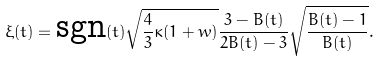Convert formula to latex. <formula><loc_0><loc_0><loc_500><loc_500>\xi ( t ) = \text {sgn} ( t ) \sqrt { \frac { 4 } { 3 } \kappa ( 1 + w ) } \frac { 3 - B ( t ) } { 2 B ( t ) - 3 } \sqrt { \frac { B ( t ) - 1 } { B ( t ) } } .</formula> 